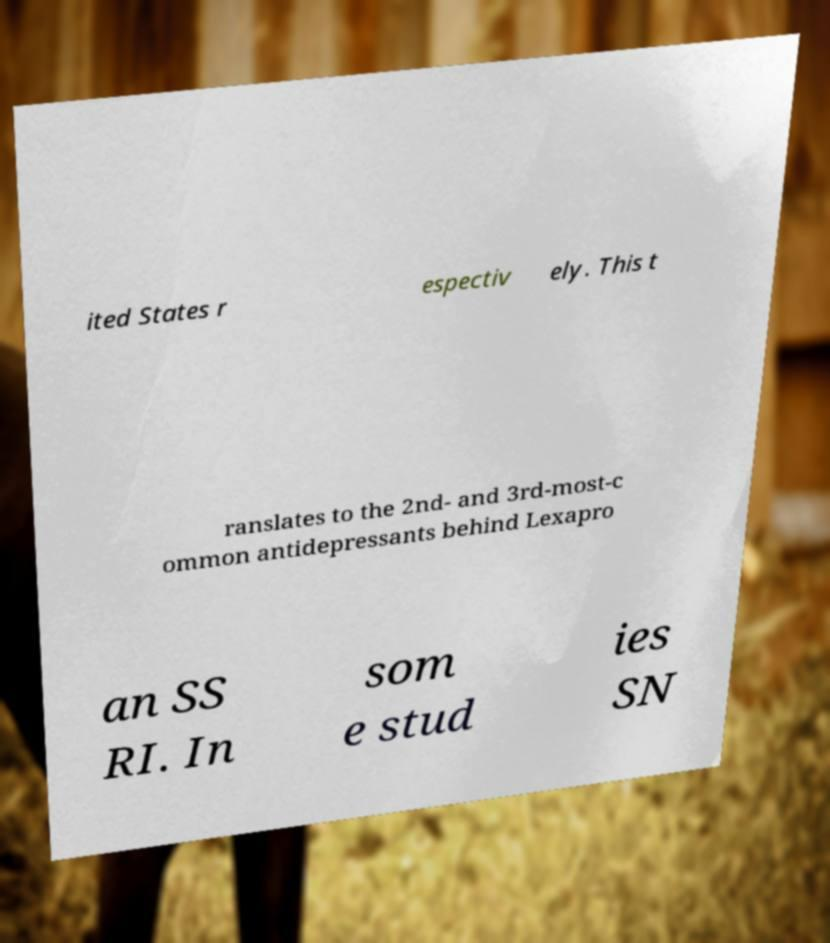I need the written content from this picture converted into text. Can you do that? ited States r espectiv ely. This t ranslates to the 2nd- and 3rd-most-c ommon antidepressants behind Lexapro an SS RI. In som e stud ies SN 